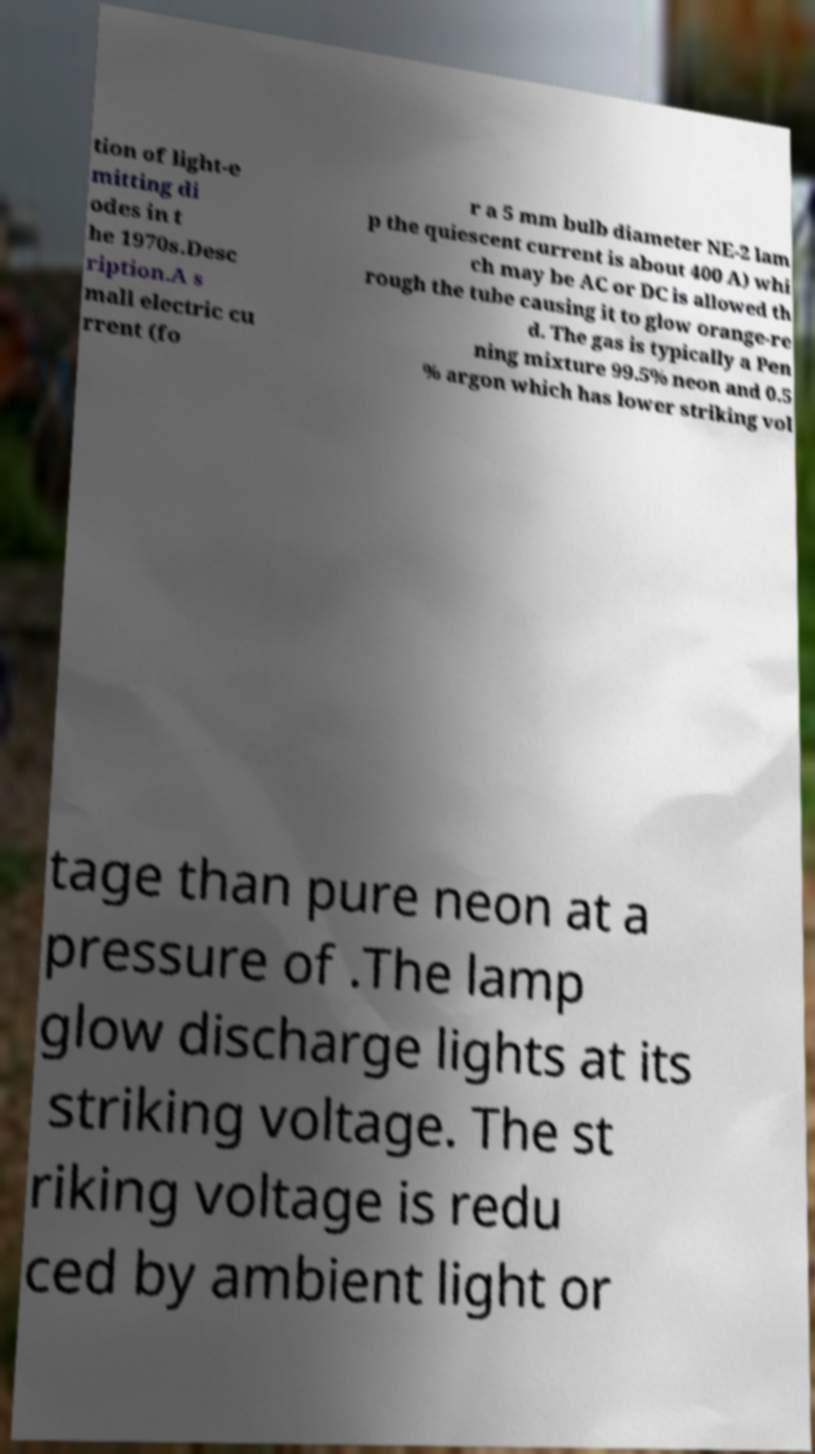Could you extract and type out the text from this image? tion of light-e mitting di odes in t he 1970s.Desc ription.A s mall electric cu rrent (fo r a 5 mm bulb diameter NE-2 lam p the quiescent current is about 400 A) whi ch may be AC or DC is allowed th rough the tube causing it to glow orange-re d. The gas is typically a Pen ning mixture 99.5% neon and 0.5 % argon which has lower striking vol tage than pure neon at a pressure of .The lamp glow discharge lights at its striking voltage. The st riking voltage is redu ced by ambient light or 